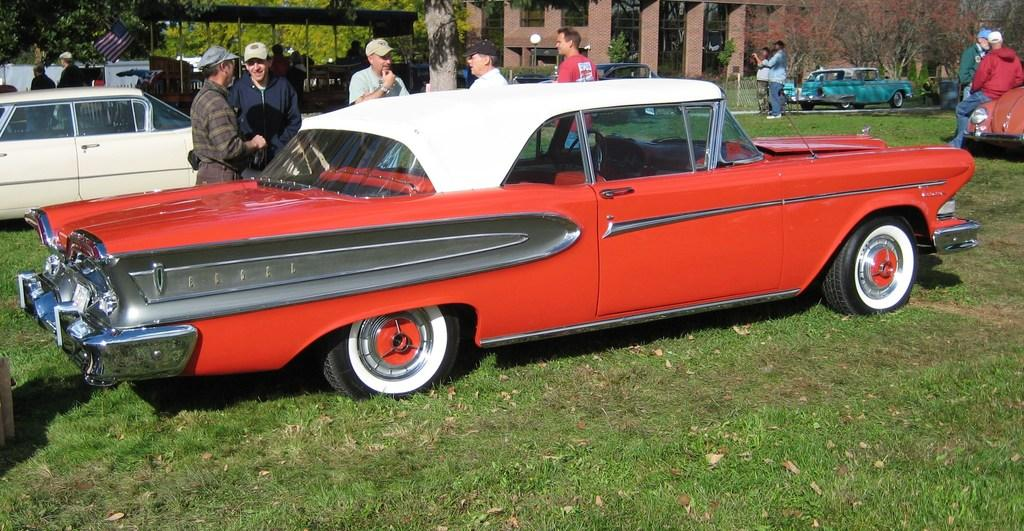What type of vehicles can be seen in the image? There are cars in the image. Who or what else is present in the image? There are people in the image. What is the landscape like in the image? The land is grassy. Can you describe the background of the image? In the background, there are cars visible on a road, a fence, trees, buildings, a flag, and a shelter. What type of nail is being used to hold the question in the image? There is no nail or question present in the image. What suggestion is being made by the people in the image? The image does not depict any suggestions being made by the people. 